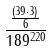Convert formula to latex. <formula><loc_0><loc_0><loc_500><loc_500>\frac { \frac { ( 3 9 \cdot 3 ) } { 6 } } { 1 8 9 ^ { 2 2 0 } }</formula> 